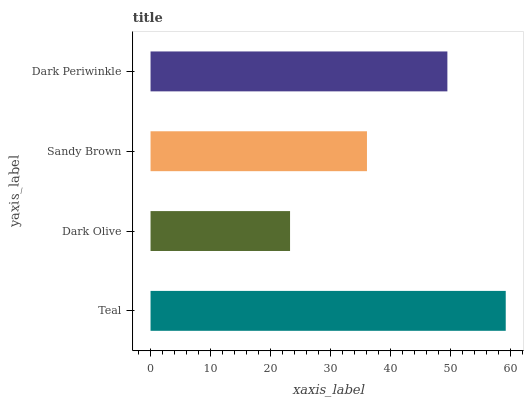Is Dark Olive the minimum?
Answer yes or no. Yes. Is Teal the maximum?
Answer yes or no. Yes. Is Sandy Brown the minimum?
Answer yes or no. No. Is Sandy Brown the maximum?
Answer yes or no. No. Is Sandy Brown greater than Dark Olive?
Answer yes or no. Yes. Is Dark Olive less than Sandy Brown?
Answer yes or no. Yes. Is Dark Olive greater than Sandy Brown?
Answer yes or no. No. Is Sandy Brown less than Dark Olive?
Answer yes or no. No. Is Dark Periwinkle the high median?
Answer yes or no. Yes. Is Sandy Brown the low median?
Answer yes or no. Yes. Is Dark Olive the high median?
Answer yes or no. No. Is Dark Periwinkle the low median?
Answer yes or no. No. 